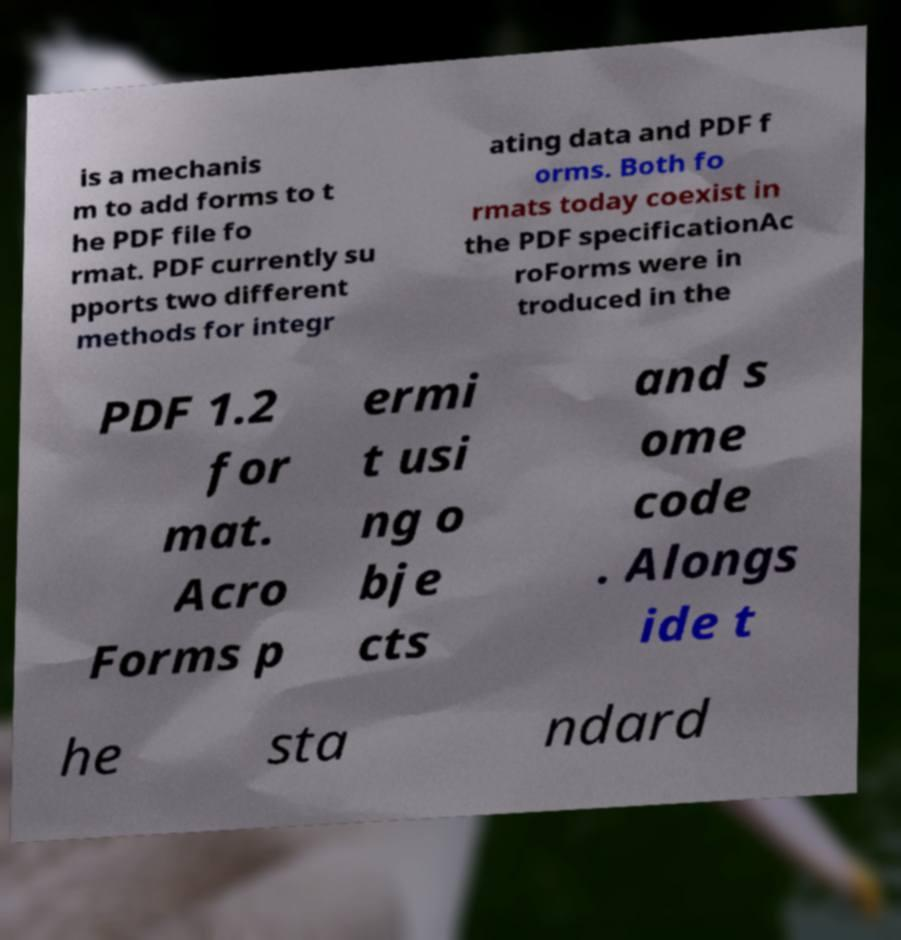For documentation purposes, I need the text within this image transcribed. Could you provide that? is a mechanis m to add forms to t he PDF file fo rmat. PDF currently su pports two different methods for integr ating data and PDF f orms. Both fo rmats today coexist in the PDF specificationAc roForms were in troduced in the PDF 1.2 for mat. Acro Forms p ermi t usi ng o bje cts and s ome code . Alongs ide t he sta ndard 